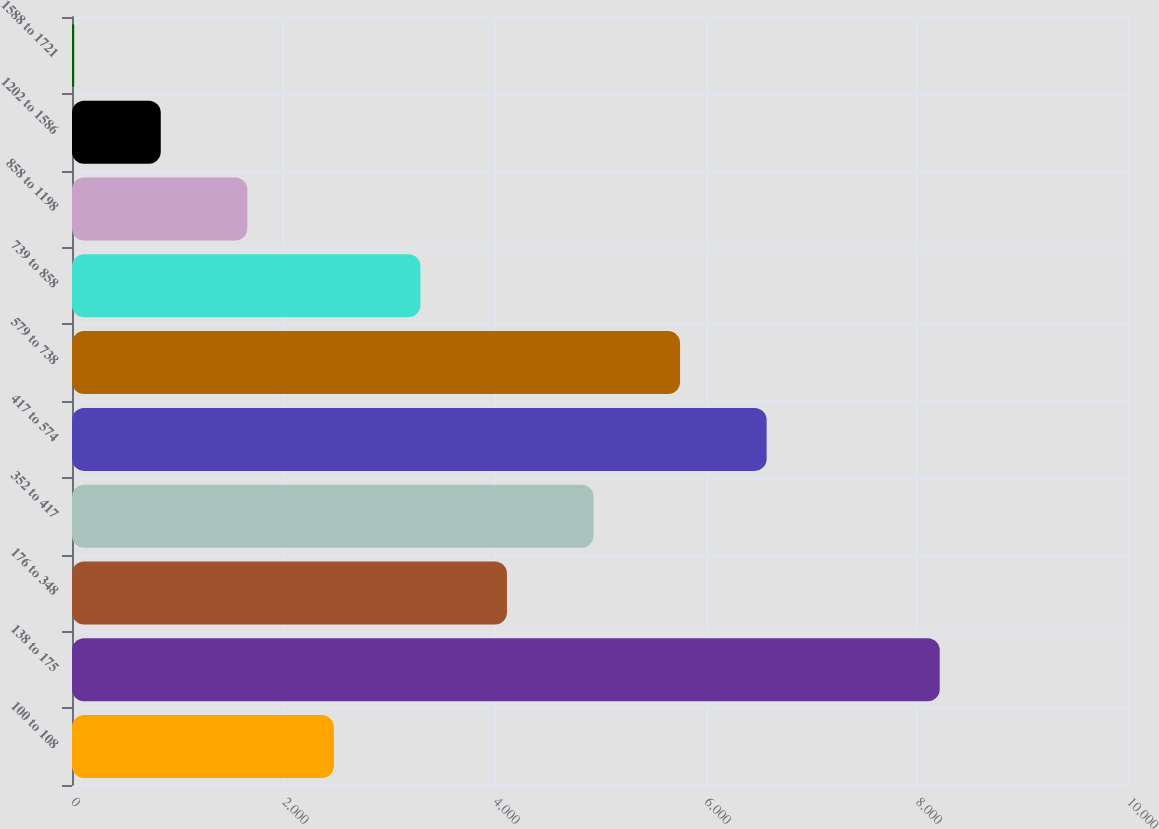<chart> <loc_0><loc_0><loc_500><loc_500><bar_chart><fcel>100 to 108<fcel>138 to 175<fcel>176 to 348<fcel>352 to 417<fcel>417 to 574<fcel>579 to 738<fcel>739 to 858<fcel>858 to 1198<fcel>1202 to 1586<fcel>1588 to 1721<nl><fcel>2479.8<fcel>8217<fcel>4119<fcel>4938.6<fcel>6577.8<fcel>5758.2<fcel>3299.4<fcel>1660.2<fcel>840.6<fcel>21<nl></chart> 